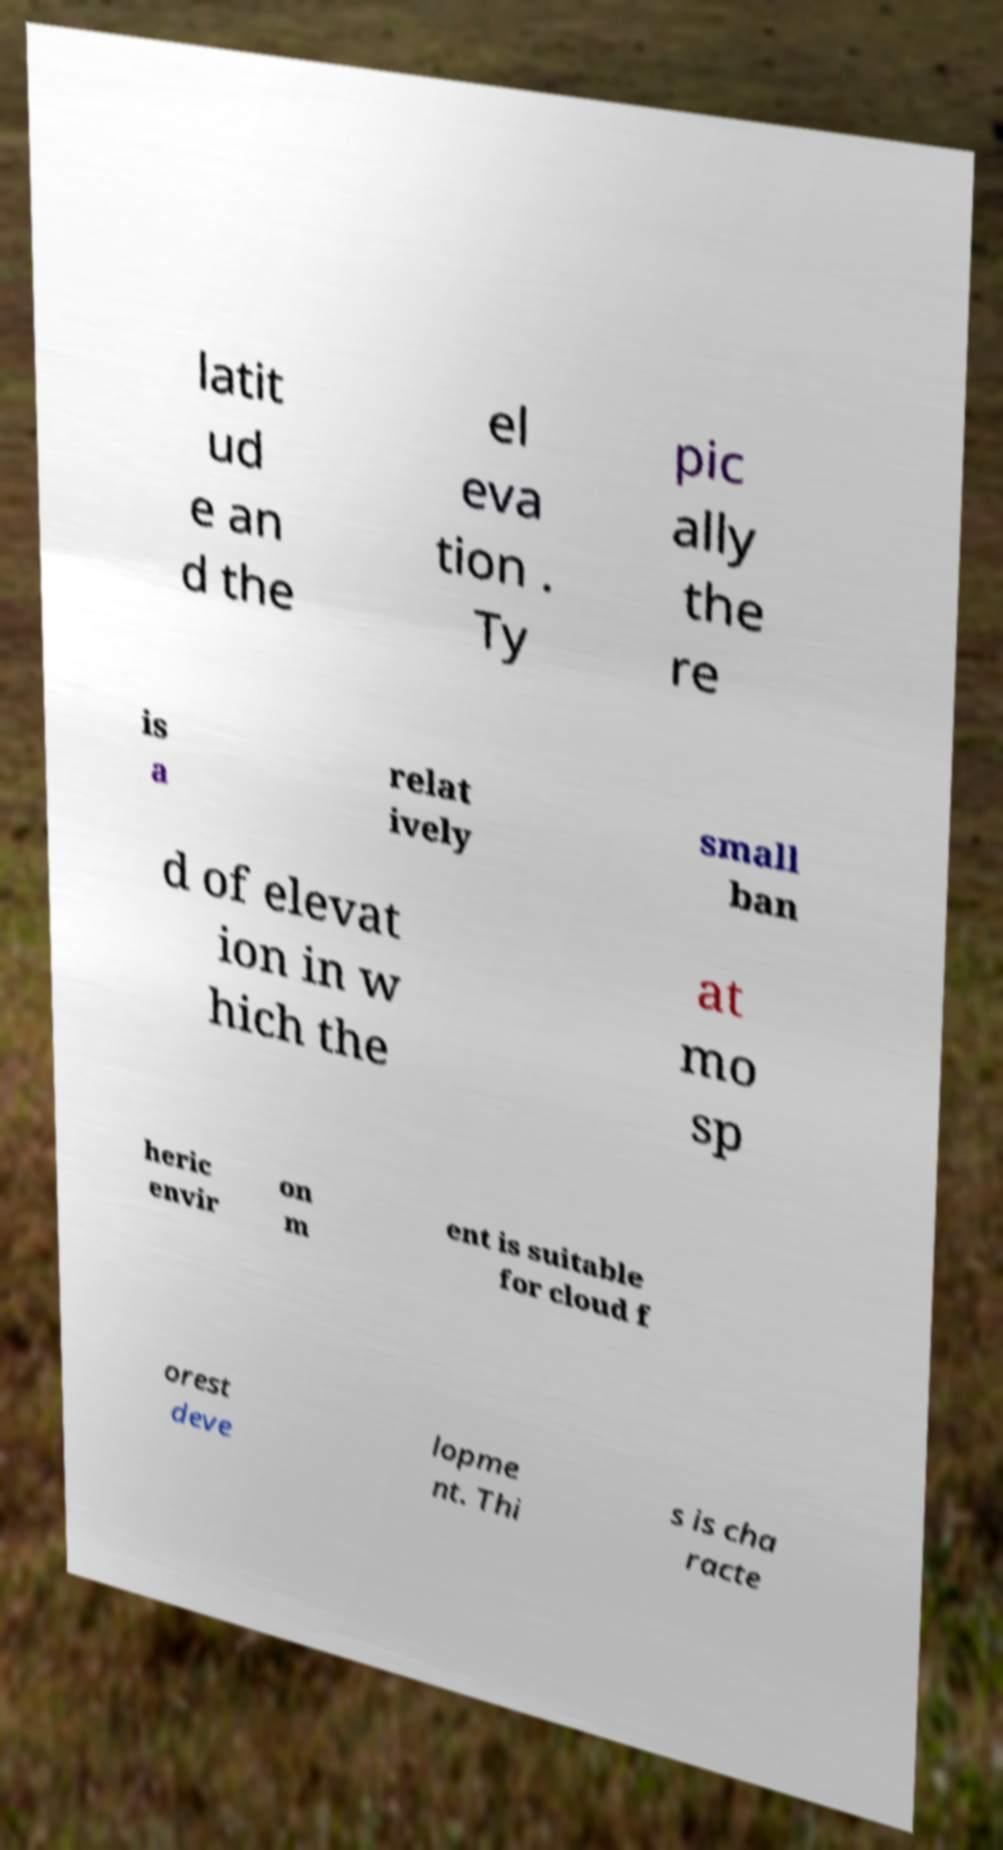What messages or text are displayed in this image? I need them in a readable, typed format. latit ud e an d the el eva tion . Ty pic ally the re is a relat ively small ban d of elevat ion in w hich the at mo sp heric envir on m ent is suitable for cloud f orest deve lopme nt. Thi s is cha racte 